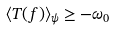Convert formula to latex. <formula><loc_0><loc_0><loc_500><loc_500>\langle T ( f ) \rangle _ { \psi } \geq - \omega _ { 0 }</formula> 